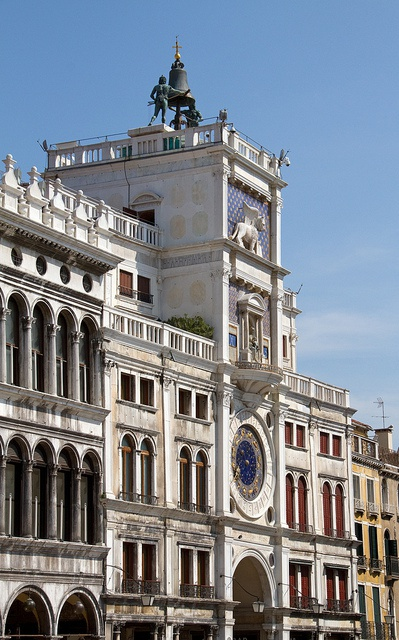Describe the objects in this image and their specific colors. I can see clock in gray, navy, and black tones and people in gray, black, and blue tones in this image. 